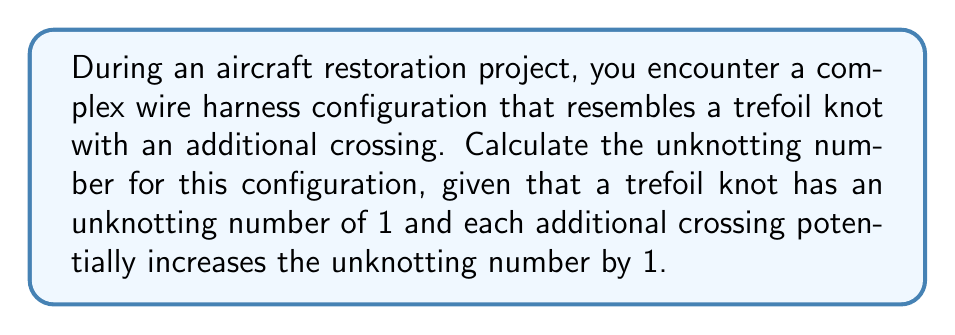Could you help me with this problem? To solve this problem, we'll follow these steps:

1. Recall the unknotting number of a trefoil knot:
   The trefoil knot has an unknotting number of 1.

2. Consider the additional crossing:
   Each additional crossing can potentially increase the unknotting number by 1.

3. Calculate the new unknotting number:
   $$u(K) = u(\text{trefoil}) + u(\text{additional crossing})$$
   $$u(K) = 1 + 1 = 2$$

4. Verify the result:
   The unknotting number cannot exceed the number of crossings in the knot diagram. In this case, we have a trefoil (3 crossings) plus one additional crossing, totaling 4 crossings. Our calculated unknotting number (2) is less than or equal to the number of crossings, so it's a valid result.

5. Interpret the result:
   An unknotting number of 2 means that a minimum of two crossing changes are required to transform this complex wire harness configuration into an unknot (a simple loop with no crossings).

[asy]
import geometry;

size(100);

path p = (0,0)--(1,1)--(2,0)--(1,-1)--cycle;
path q = (0.5,0.5)--(1.5,-0.5);

draw(p);
draw(q);

dot((0,0));
dot((1,1));
dot((2,0));
dot((1,-1));
dot((0.5,0.5));
dot((1.5,-0.5));
[/asy]
Answer: 2 